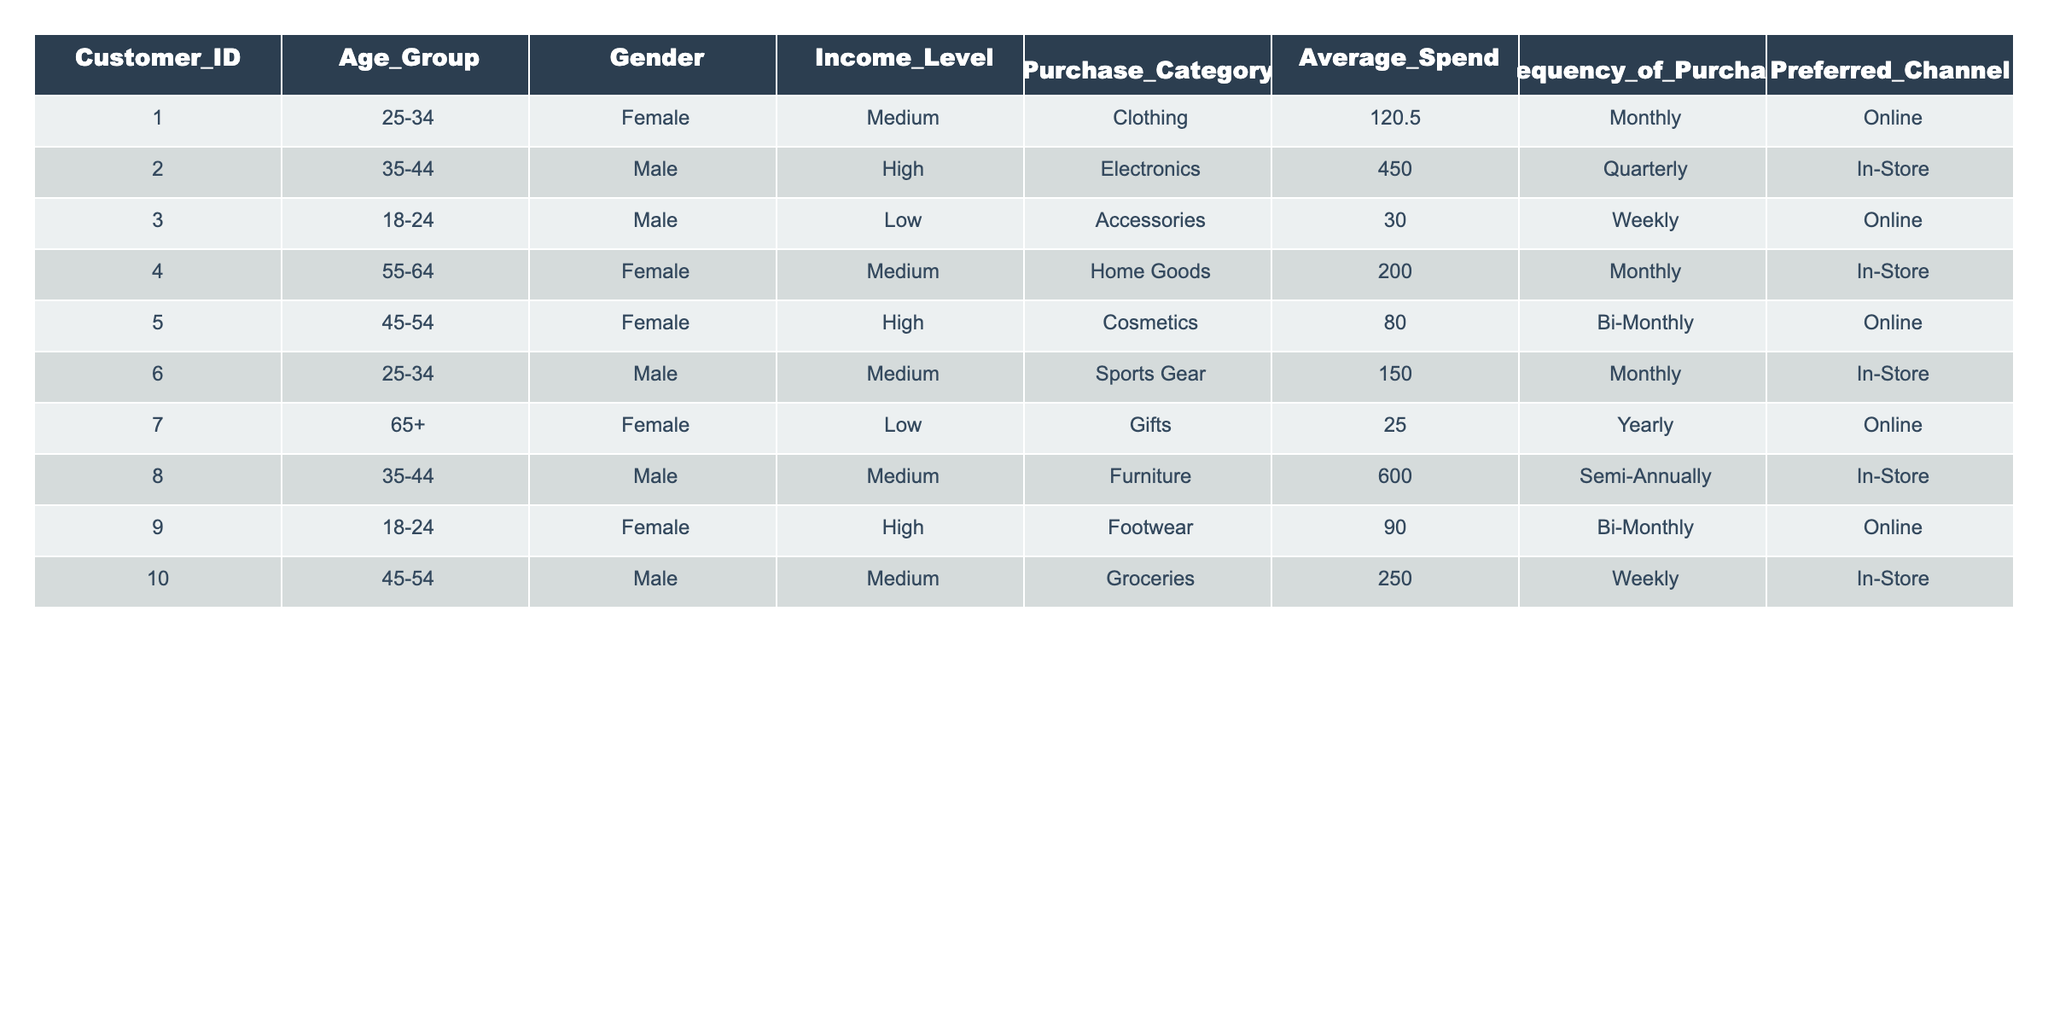What is the average spend of customers in the 'Female' gender category? There are 5 entries for Female. Their average spend values are: 120.50, 200.00, 80.00, 90.00, and 25.00. Summing these up gives (120.50 + 200.00 + 80.00 + 90.00 + 25.00) = 515.50. Dividing by 5 gives 515.50 / 5 = 103.10.
Answer: 103.10 Which age group has the highest average spend, and what is that value? The age groups and their average spends are: 25-34 (120.50, 150.00), 35-44 (450.00, 600.00), 18-24 (30.00, 90.00), 55-64 (200.00), and 65+ (25.00). The highest is from 35-44 with (450.00 + 600.00) / 2 = 525.00.
Answer: 35-44, 525.00 Is there a customer from the 'Low' income level who purchases online? Looking through the entries, Customer 3 (18-24, Male, Low, Accessories) and Customer 7 (65+, Female, Low, Gifts) both purchase online.
Answer: Yes What is the total frequency of purchases made by customers within the 'Medium' income level? The frequency of customers in the Medium income level are: Monthly (2), Bi-Monthly (1), and Weekly (2). Adding these gives 2 + 1 + 2 = 5 total frequencies.
Answer: 5 Which purchasing category has the highest total average spend, and what is that amount? The categories and their average spends are: Clothing (120.50), Electronics (450.00), Accessories (30.00), Home Goods (200.00), Cosmetics (80.00), Sports Gear (150.00), Gifts (25.00), Furniture (600.00), Footwear (90.00), and Groceries (250.00). The highest is Furniture at 600.00.
Answer: Furniture, 600.00 Which channel has the most customers preferring it, and how many customers does that represent? The preferred channels and respective counts are: Online (5), In-Store (5). Both channels have equal counts, with 5 customers each.
Answer: Online and In-Store, 5 customers each Is the statement true that all customers purchasing in 'Cosmetics' are Females? The entry for Cosmetics shows Customer 5 (45-54, Female, High). There is only one customer in this category, and that customer is Female.
Answer: True What is the median average spend for customers aged 25-34? The average spends for the 25-34 age group are: 120.50 and 150.00. The median is the average of the two middle numbers, which equals (120.50 + 150.00) / 2 = 135.25.
Answer: 135.25 Among all customers, how many purchase quarterly, and what is their average spend? Customer 2 purchases quarterly at 450.00, which gives a total of 1 customer and an average spend of 450.00.
Answer: 1, 450.00 What is the total average spend for customers who prefer purchasing online? The average spends for Online customers are: 120.50, 30.00, 80.00, 90.00, and 25.00. Adding these gives 120.50 + 30.00 + 80.00 + 90.00 + 25.00 = 345.50. Dividing by 5 gives 345.50 / 5 = 69.10.
Answer: 69.10 